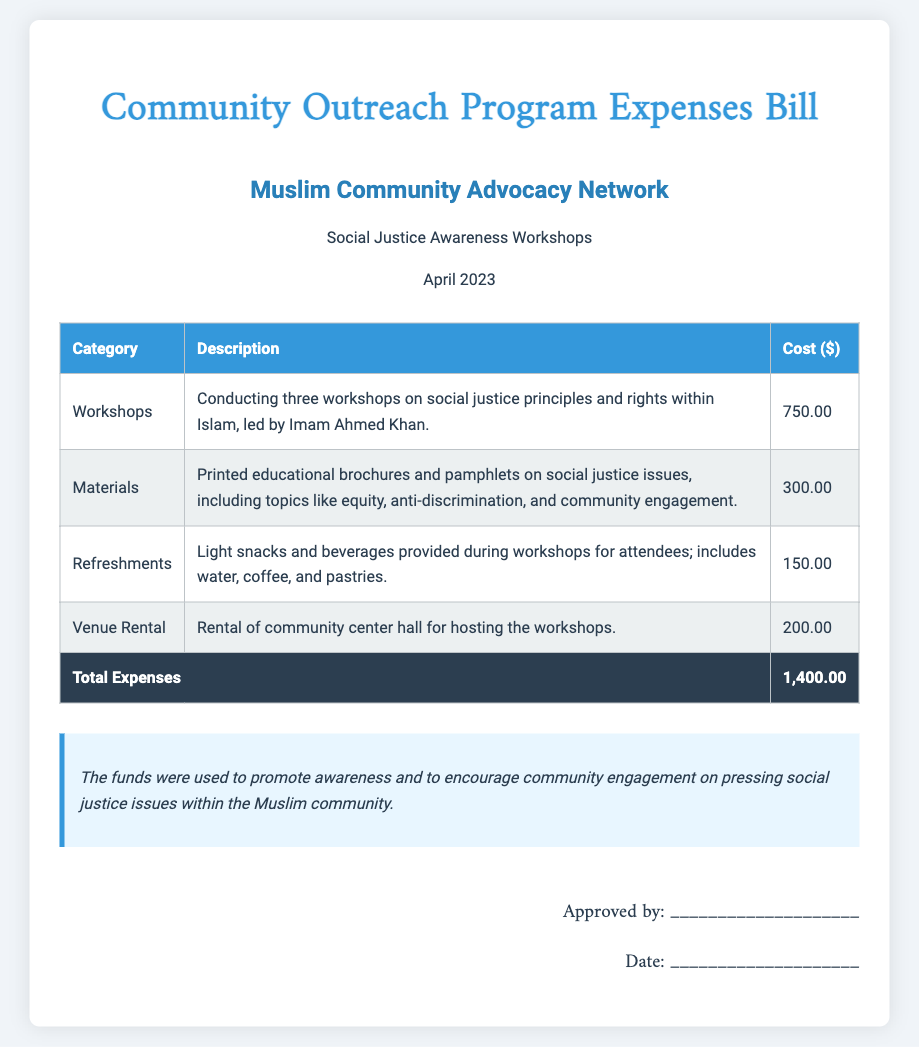What is the total cost of the workshops? The total cost of the workshops refers to the amount spent on conducting three workshops detailed in the document.
Answer: 750.00 What type of organization is mentioned? The document refers to the Muslim Community Advocacy Network, indicating the type of organization responsible for the outreach program.
Answer: Muslim Community Advocacy Network Who led the workshops? The document specifies that Imam Ahmed Khan conducted the workshops, providing information on the leader of these sessions.
Answer: Imam Ahmed Khan What is the cost of materials? The document lists the cost associated with printed educational brochures and pamphlets, providing the specific expense amount for materials.
Answer: 300.00 What was included in refreshments? The document describes the type of snacks and drinks provided during the workshops, revealing what was served to attendees.
Answer: Water, coffee, and pastries What is the purpose of the funds? The document contains a notes section that explains the objective of the expenses listed, summarizing the intent behind using the funds.
Answer: Promote awareness What was the cost of venue rental? The total amount allocated for renting the community center hall for hosting workshops is specified in the bill.
Answer: 200.00 What month is the bill for? The document indicates the time period for the expenses being reported, specifically mentioning the corresponding month.
Answer: April 2023 